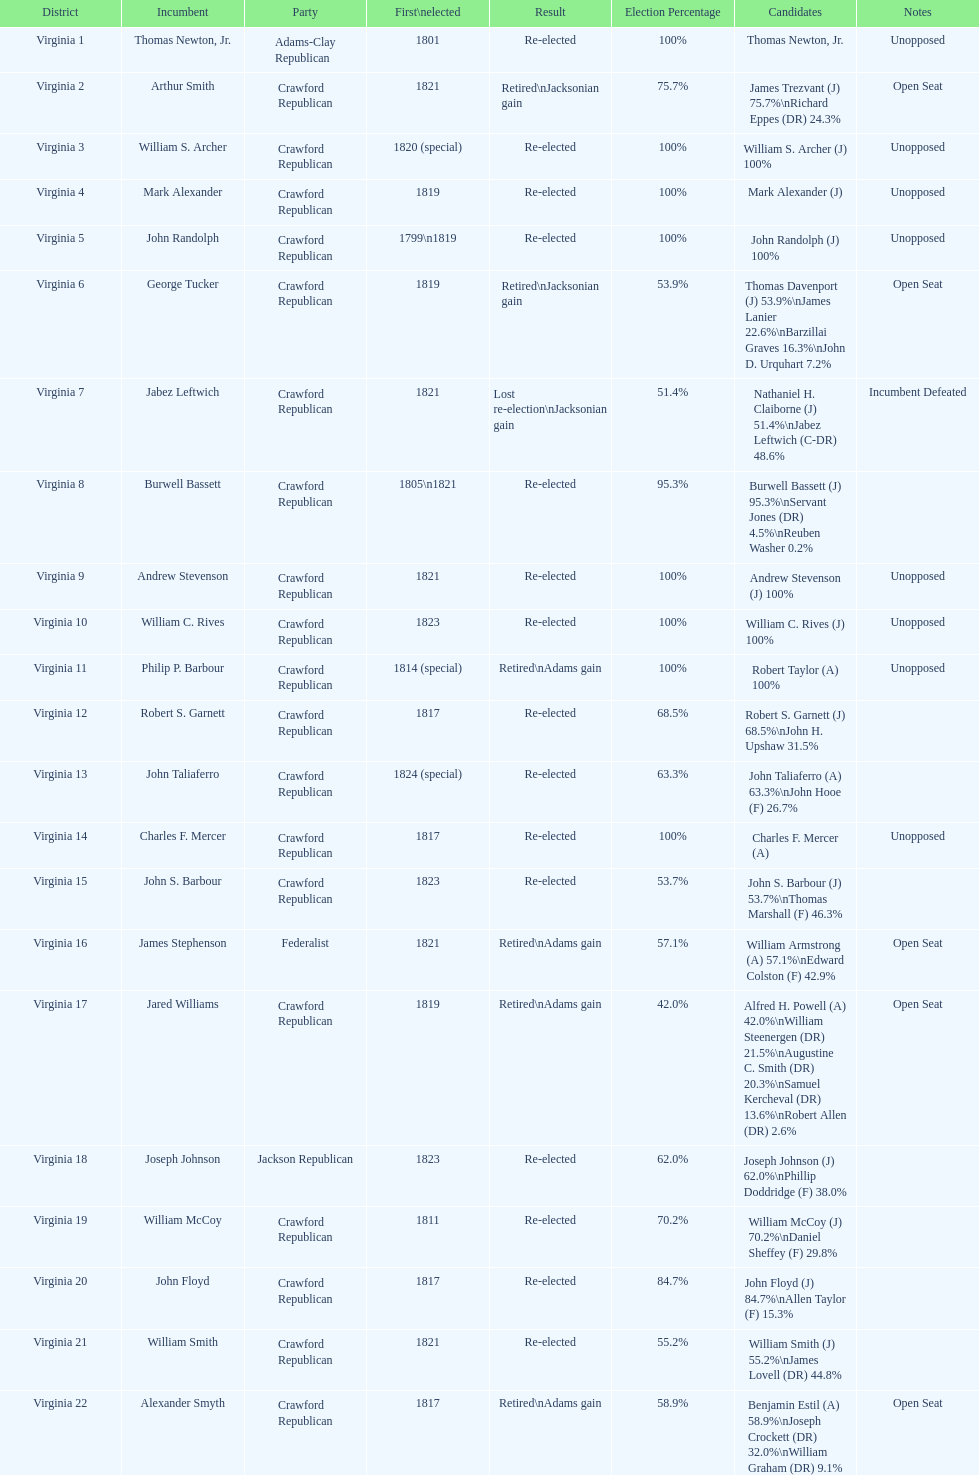Who was the next incumbent after john randolph? George Tucker. 